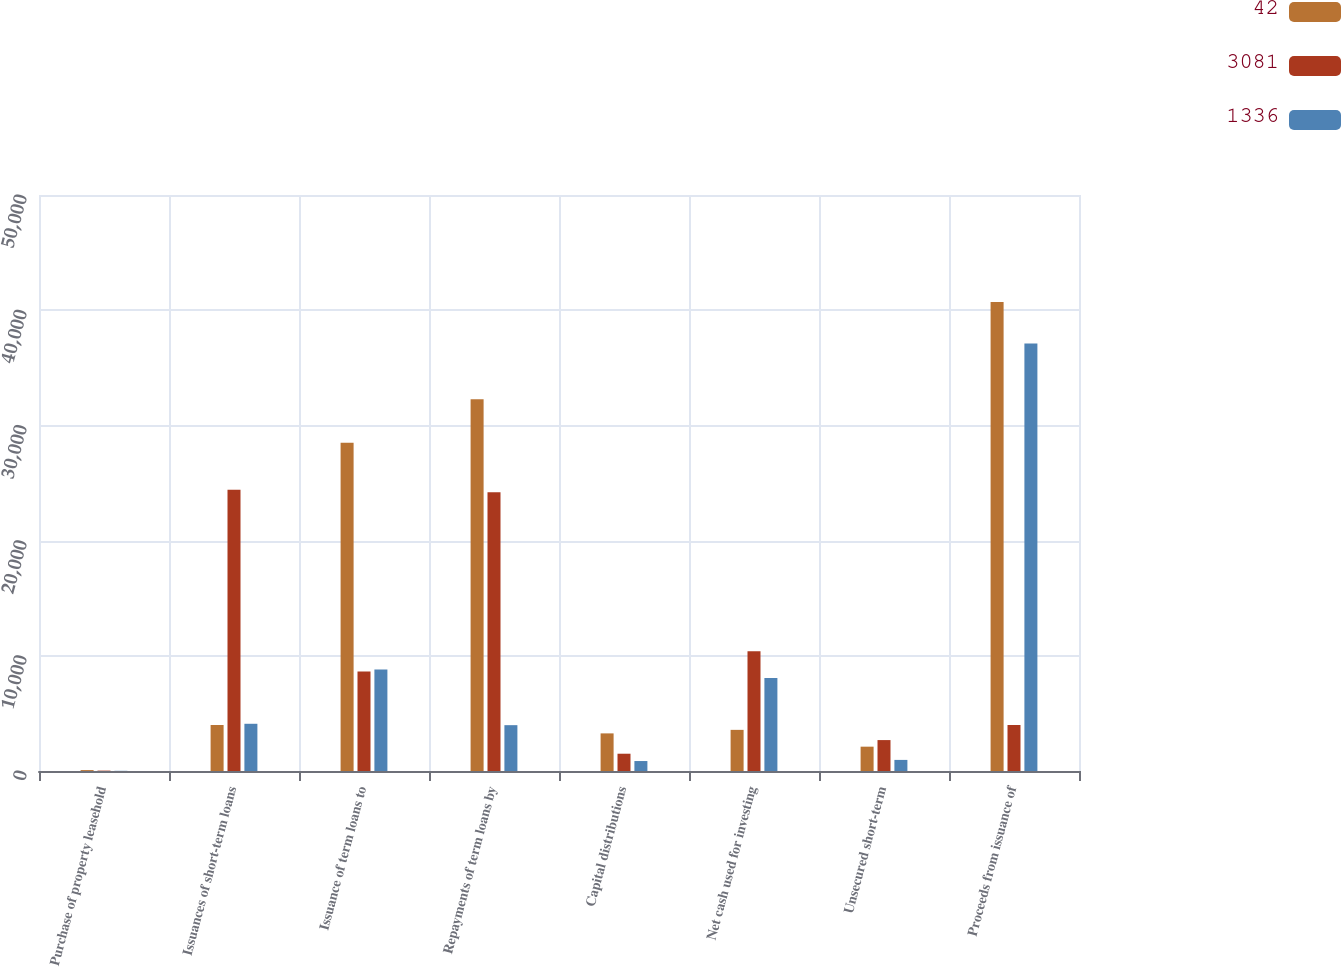Convert chart. <chart><loc_0><loc_0><loc_500><loc_500><stacked_bar_chart><ecel><fcel>Purchase of property leasehold<fcel>Issuances of short-term loans<fcel>Issuance of term loans to<fcel>Repayments of term loans by<fcel>Capital distributions<fcel>Net cash used for investing<fcel>Unsecured short-term<fcel>Proceeds from issuance of<nl><fcel>42<fcel>79<fcel>3994<fcel>28498<fcel>32265<fcel>3265<fcel>3571<fcel>2112<fcel>40708<nl><fcel>3081<fcel>33<fcel>24417<fcel>8632<fcel>24196<fcel>1500<fcel>10386<fcel>2684<fcel>3994<nl><fcel>1336<fcel>15<fcel>4099<fcel>8803<fcel>3979<fcel>865<fcel>8073<fcel>963<fcel>37101<nl></chart> 